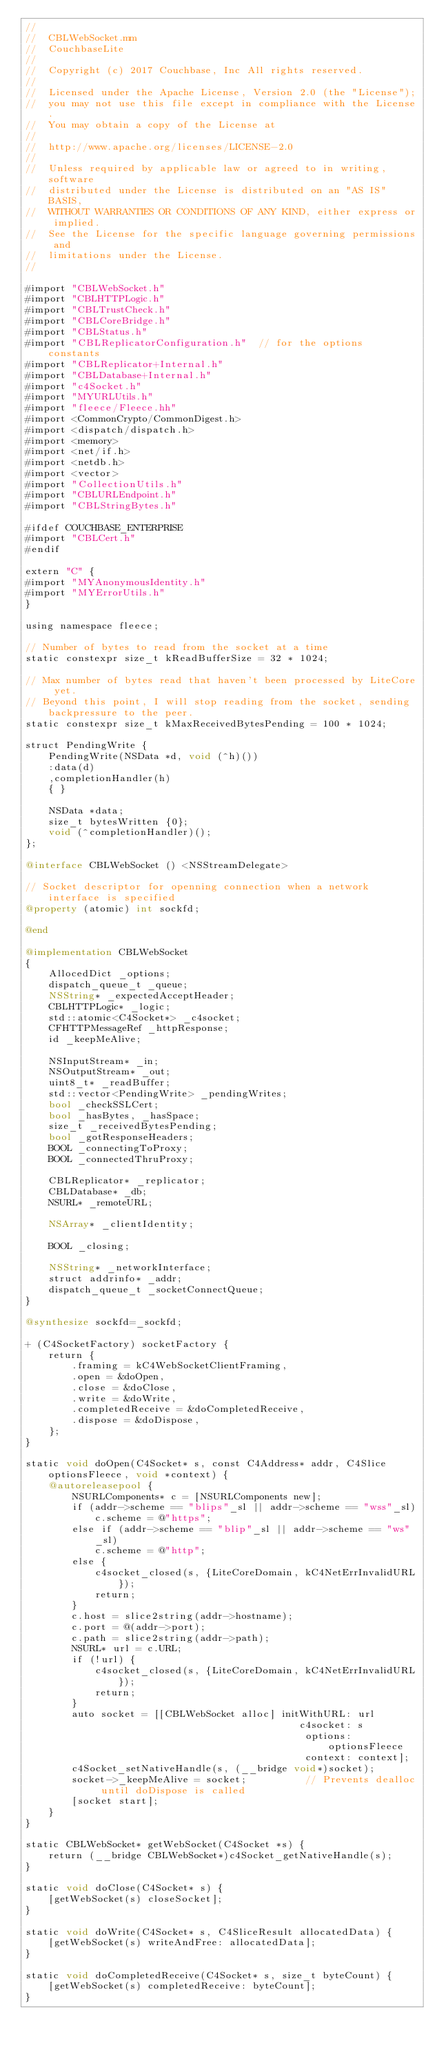Convert code to text. <code><loc_0><loc_0><loc_500><loc_500><_ObjectiveC_>//
//  CBLWebSocket.mm
//  CouchbaseLite
//
//  Copyright (c) 2017 Couchbase, Inc All rights reserved.
//
//  Licensed under the Apache License, Version 2.0 (the "License");
//  you may not use this file except in compliance with the License.
//  You may obtain a copy of the License at
//
//  http://www.apache.org/licenses/LICENSE-2.0
//
//  Unless required by applicable law or agreed to in writing, software
//  distributed under the License is distributed on an "AS IS" BASIS,
//  WITHOUT WARRANTIES OR CONDITIONS OF ANY KIND, either express or implied.
//  See the License for the specific language governing permissions and
//  limitations under the License.
//

#import "CBLWebSocket.h"
#import "CBLHTTPLogic.h"
#import "CBLTrustCheck.h"
#import "CBLCoreBridge.h"
#import "CBLStatus.h"
#import "CBLReplicatorConfiguration.h"  // for the options constants
#import "CBLReplicator+Internal.h"
#import "CBLDatabase+Internal.h"
#import "c4Socket.h"
#import "MYURLUtils.h"
#import "fleece/Fleece.hh"
#import <CommonCrypto/CommonDigest.h>
#import <dispatch/dispatch.h>
#import <memory>
#import <net/if.h>
#import <netdb.h>
#import <vector>
#import "CollectionUtils.h"
#import "CBLURLEndpoint.h"
#import "CBLStringBytes.h"

#ifdef COUCHBASE_ENTERPRISE
#import "CBLCert.h"
#endif

extern "C" {
#import "MYAnonymousIdentity.h"
#import "MYErrorUtils.h"
}

using namespace fleece;

// Number of bytes to read from the socket at a time
static constexpr size_t kReadBufferSize = 32 * 1024;

// Max number of bytes read that haven't been processed by LiteCore yet.
// Beyond this point, I will stop reading from the socket, sending backpressure to the peer.
static constexpr size_t kMaxReceivedBytesPending = 100 * 1024;

struct PendingWrite {
    PendingWrite(NSData *d, void (^h)())
    :data(d)
    ,completionHandler(h)
    { }

    NSData *data;
    size_t bytesWritten {0};
    void (^completionHandler)();
};

@interface CBLWebSocket () <NSStreamDelegate>

// Socket descriptor for openning connection when a network interface is specified
@property (atomic) int sockfd;

@end

@implementation CBLWebSocket
{
    AllocedDict _options;
    dispatch_queue_t _queue;
    NSString* _expectedAcceptHeader;
    CBLHTTPLogic* _logic;
    std::atomic<C4Socket*> _c4socket;
    CFHTTPMessageRef _httpResponse;
    id _keepMeAlive;

    NSInputStream* _in;
    NSOutputStream* _out;
    uint8_t* _readBuffer;
    std::vector<PendingWrite> _pendingWrites;
    bool _checkSSLCert;
    bool _hasBytes, _hasSpace;
    size_t _receivedBytesPending;
    bool _gotResponseHeaders;
    BOOL _connectingToProxy;
    BOOL _connectedThruProxy;
    
    CBLReplicator* _replicator;
    CBLDatabase* _db;
    NSURL* _remoteURL;
    
    NSArray* _clientIdentity;
    
    BOOL _closing;
    
    NSString* _networkInterface;
    struct addrinfo* _addr;
    dispatch_queue_t _socketConnectQueue;
}

@synthesize sockfd=_sockfd;

+ (C4SocketFactory) socketFactory {
    return {
        .framing = kC4WebSocketClientFraming,
        .open = &doOpen,
        .close = &doClose,
        .write = &doWrite,
        .completedReceive = &doCompletedReceive,
        .dispose = &doDispose,
    };
}

static void doOpen(C4Socket* s, const C4Address* addr, C4Slice optionsFleece, void *context) {
    @autoreleasepool {
        NSURLComponents* c = [NSURLComponents new];
        if (addr->scheme == "blips"_sl || addr->scheme == "wss"_sl)
            c.scheme = @"https";
        else if (addr->scheme == "blip"_sl || addr->scheme == "ws"_sl)
            c.scheme = @"http";
        else {
            c4socket_closed(s, {LiteCoreDomain, kC4NetErrInvalidURL});
            return;
        }
        c.host = slice2string(addr->hostname);
        c.port = @(addr->port);
        c.path = slice2string(addr->path);
        NSURL* url = c.URL;
        if (!url) {
            c4socket_closed(s, {LiteCoreDomain, kC4NetErrInvalidURL});
            return;
        }
        auto socket = [[CBLWebSocket alloc] initWithURL: url
                                               c4socket: s
                                                options: optionsFleece
                                                context: context];
        c4Socket_setNativeHandle(s, (__bridge void*)socket);
        socket->_keepMeAlive = socket;          // Prevents dealloc until doDispose is called
        [socket start];
    }
}

static CBLWebSocket* getWebSocket(C4Socket *s) {
    return (__bridge CBLWebSocket*)c4Socket_getNativeHandle(s);
}

static void doClose(C4Socket* s) {
    [getWebSocket(s) closeSocket];
}

static void doWrite(C4Socket* s, C4SliceResult allocatedData) {
    [getWebSocket(s) writeAndFree: allocatedData];
}

static void doCompletedReceive(C4Socket* s, size_t byteCount) {
    [getWebSocket(s) completedReceive: byteCount];
}
</code> 